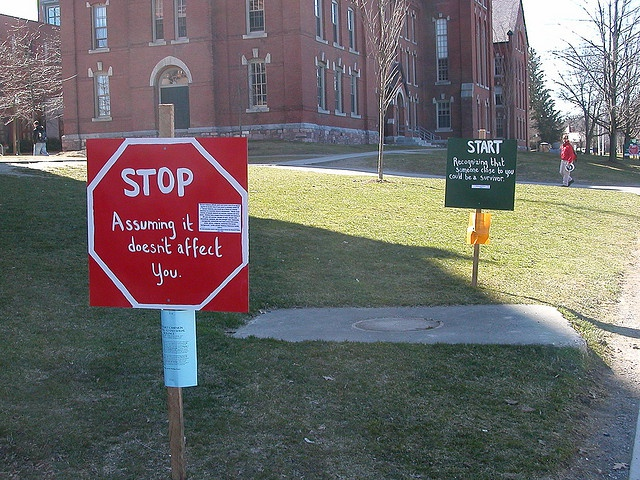Describe the objects in this image and their specific colors. I can see stop sign in white, brown, darkgray, and lavender tones, people in white, darkgray, brown, gray, and lavender tones, people in white, black, gray, and darkgray tones, backpack in white, black, gray, and blue tones, and people in white, gray, darkgray, and black tones in this image. 